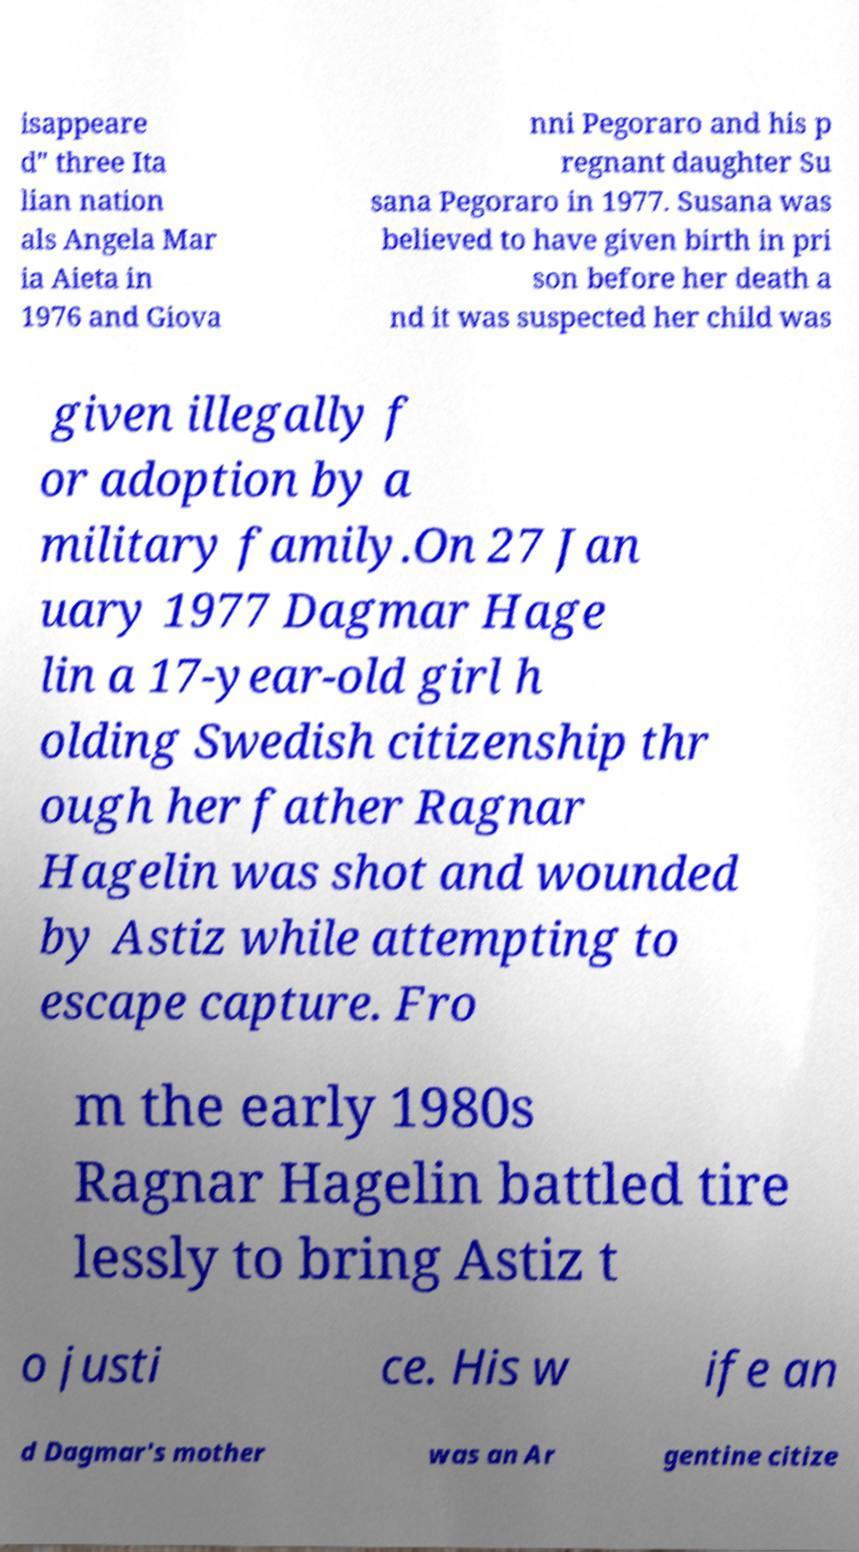I need the written content from this picture converted into text. Can you do that? isappeare d" three Ita lian nation als Angela Mar ia Aieta in 1976 and Giova nni Pegoraro and his p regnant daughter Su sana Pegoraro in 1977. Susana was believed to have given birth in pri son before her death a nd it was suspected her child was given illegally f or adoption by a military family.On 27 Jan uary 1977 Dagmar Hage lin a 17-year-old girl h olding Swedish citizenship thr ough her father Ragnar Hagelin was shot and wounded by Astiz while attempting to escape capture. Fro m the early 1980s Ragnar Hagelin battled tire lessly to bring Astiz t o justi ce. His w ife an d Dagmar's mother was an Ar gentine citize 